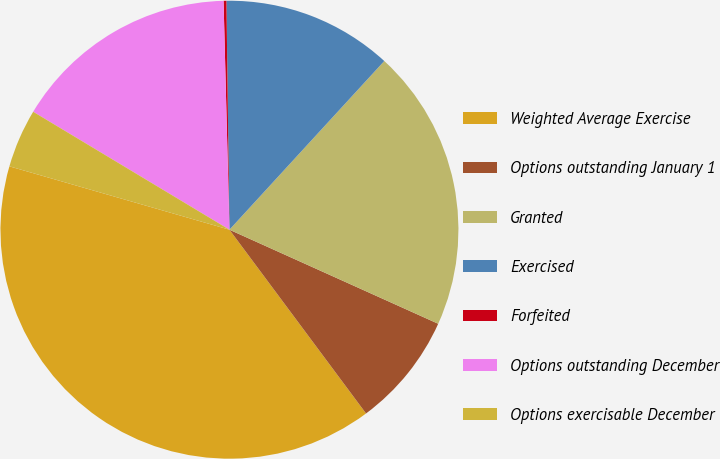<chart> <loc_0><loc_0><loc_500><loc_500><pie_chart><fcel>Weighted Average Exercise<fcel>Options outstanding January 1<fcel>Granted<fcel>Exercised<fcel>Forfeited<fcel>Options outstanding December<fcel>Options exercisable December<nl><fcel>39.64%<fcel>8.09%<fcel>19.92%<fcel>12.03%<fcel>0.2%<fcel>15.98%<fcel>4.15%<nl></chart> 